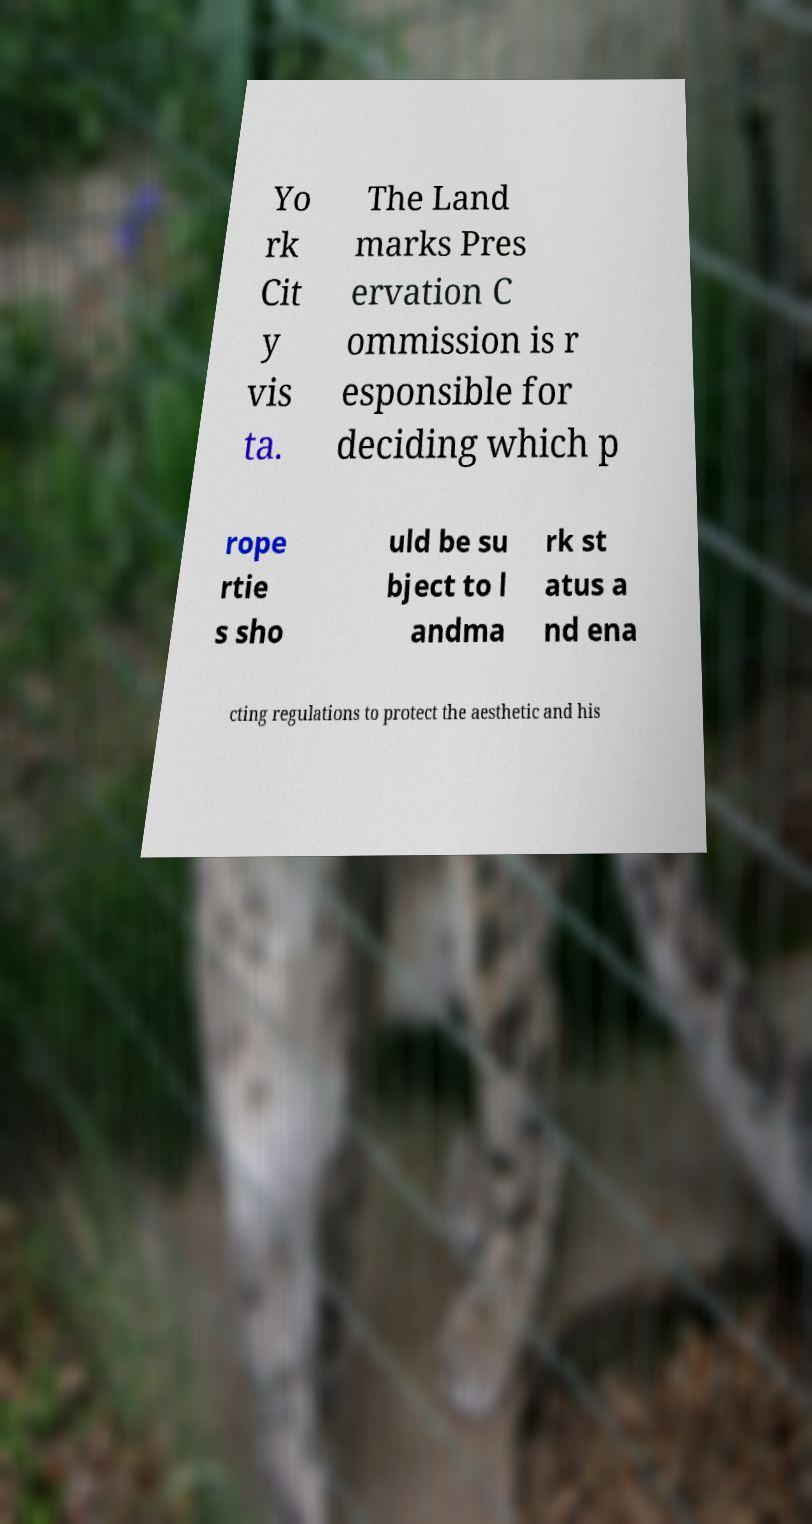Can you accurately transcribe the text from the provided image for me? Yo rk Cit y vis ta. The Land marks Pres ervation C ommission is r esponsible for deciding which p rope rtie s sho uld be su bject to l andma rk st atus a nd ena cting regulations to protect the aesthetic and his 